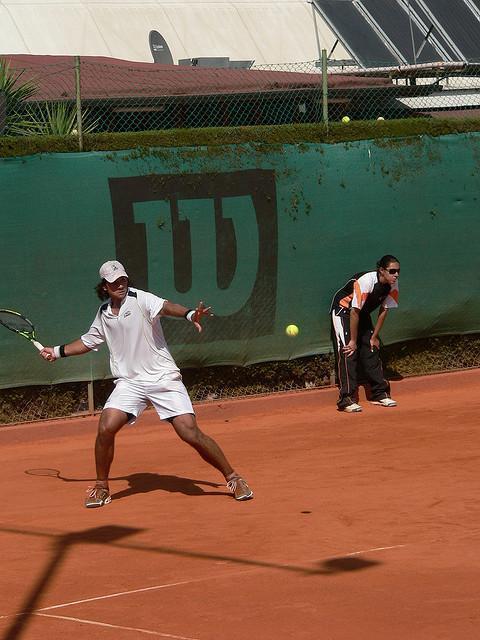What company is sponsoring the tennis match?
Select the correct answer and articulate reasoning with the following format: 'Answer: answer
Rationale: rationale.'
Options: Dunlop, asics, gamma, wilson. Answer: wilson.
Rationale: The logo of the company, a lowercase letter w, is visible on the tarp covering the court's fence. What powers the facilities in this area?
Select the accurate answer and provide explanation: 'Answer: answer
Rationale: rationale.'
Options: Pedaling, hydronics, solar, steam. Answer: solar.
Rationale: There are solar panels in the background which is a source of power and the only one currently visible. 